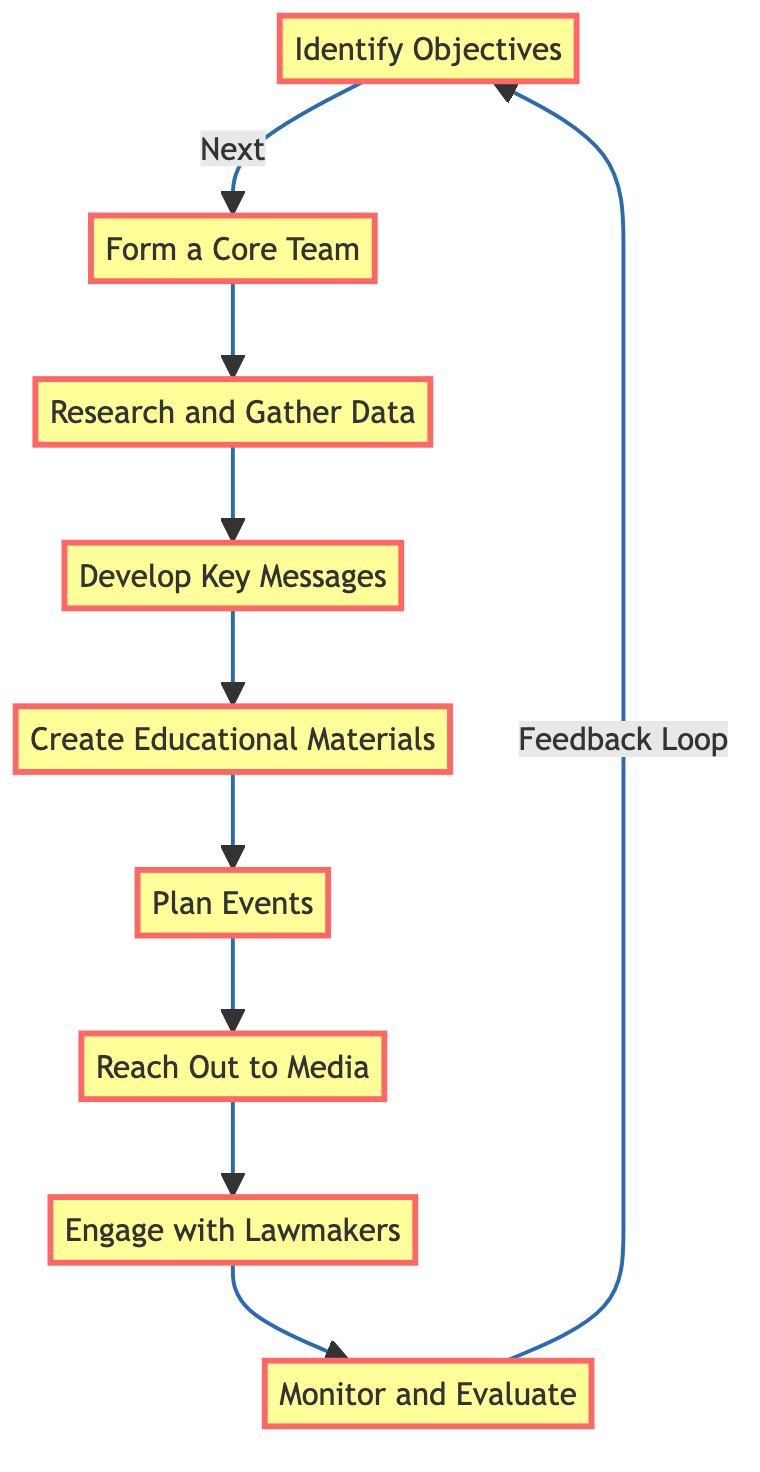What is the first step in the campaign? The diagram indicates that the first step to be taken is "Identify Objectives." This is the starting point of the flowchart and is visually the first node.
Answer: Identify Objectives How many total steps are outlined in the campaign? By counting the number of nodes in the flowchart, we observe that there are eight distinct steps listed, from "Identify Objectives" to "Monitor and Evaluate."
Answer: Eight What is the direct connection from "Plan Events"? According to the diagram, directly following "Plan Events," the next step is "Reach Out to Media." This relationship is indicated by the arrow leading from one node to another.
Answer: Reach Out to Media Which step occurs directly after "Research and Gather Data"? The flowchart shows that "Develop Key Messages" follows "Research and Gather Data." This progression is clear in the visual flow of the diagram.
Answer: Develop Key Messages What step involves engaging with lawmakers? The diagram specifies "Engage with Lawmakers" as the step where interaction with local and state legislators occurs. This is the eighth step in the sequence.
Answer: Engage with Lawmakers How does the campaign account for feedback? The diagram illustrates a feedback loop where "Monitor and Evaluate" connects back to "Identify Objectives," indicating that there is a process to reassess and improve the campaign based on evaluation findings.
Answer: Feedback Loop Which steps are highlighted in the diagram? Every step in the flowchart is highlighted, including "Identify Objectives," "Form a Core Team," "Research and Gather Data," "Develop Key Messages," "Create Educational Materials," "Plan Events," "Reach Out to Media," "Engage with Lawmakers," and "Monitor and Evaluate."
Answer: All steps What is the goal of the campaign? While the diagram does not explicitly state the goal, the first step "Identify Objectives" suggests that the goal involves educating the public and advocating for policy change regarding the three-strikes rule.
Answer: Educating the public and advocating for policy change 